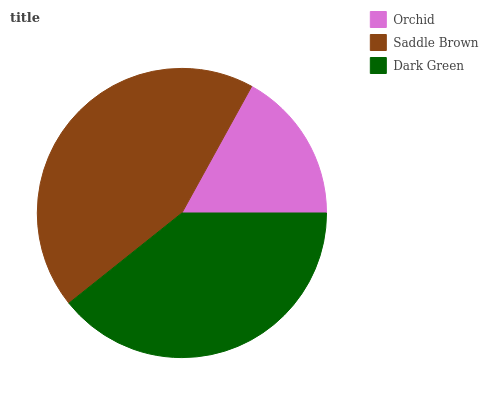Is Orchid the minimum?
Answer yes or no. Yes. Is Saddle Brown the maximum?
Answer yes or no. Yes. Is Dark Green the minimum?
Answer yes or no. No. Is Dark Green the maximum?
Answer yes or no. No. Is Saddle Brown greater than Dark Green?
Answer yes or no. Yes. Is Dark Green less than Saddle Brown?
Answer yes or no. Yes. Is Dark Green greater than Saddle Brown?
Answer yes or no. No. Is Saddle Brown less than Dark Green?
Answer yes or no. No. Is Dark Green the high median?
Answer yes or no. Yes. Is Dark Green the low median?
Answer yes or no. Yes. Is Orchid the high median?
Answer yes or no. No. Is Saddle Brown the low median?
Answer yes or no. No. 